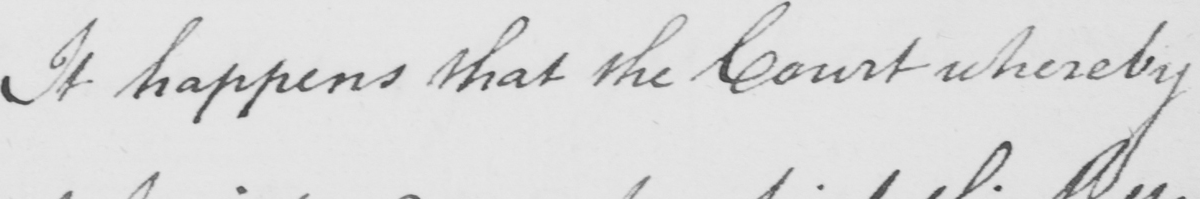What does this handwritten line say? It happens that the Court whereby 